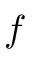<formula> <loc_0><loc_0><loc_500><loc_500>f</formula> 